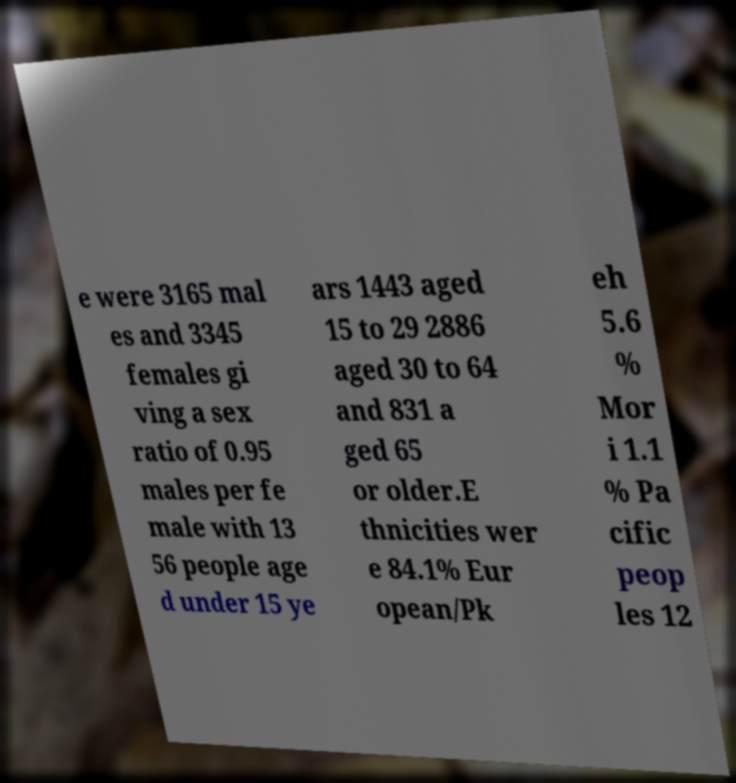Please identify and transcribe the text found in this image. e were 3165 mal es and 3345 females gi ving a sex ratio of 0.95 males per fe male with 13 56 people age d under 15 ye ars 1443 aged 15 to 29 2886 aged 30 to 64 and 831 a ged 65 or older.E thnicities wer e 84.1% Eur opean/Pk eh 5.6 % Mor i 1.1 % Pa cific peop les 12 